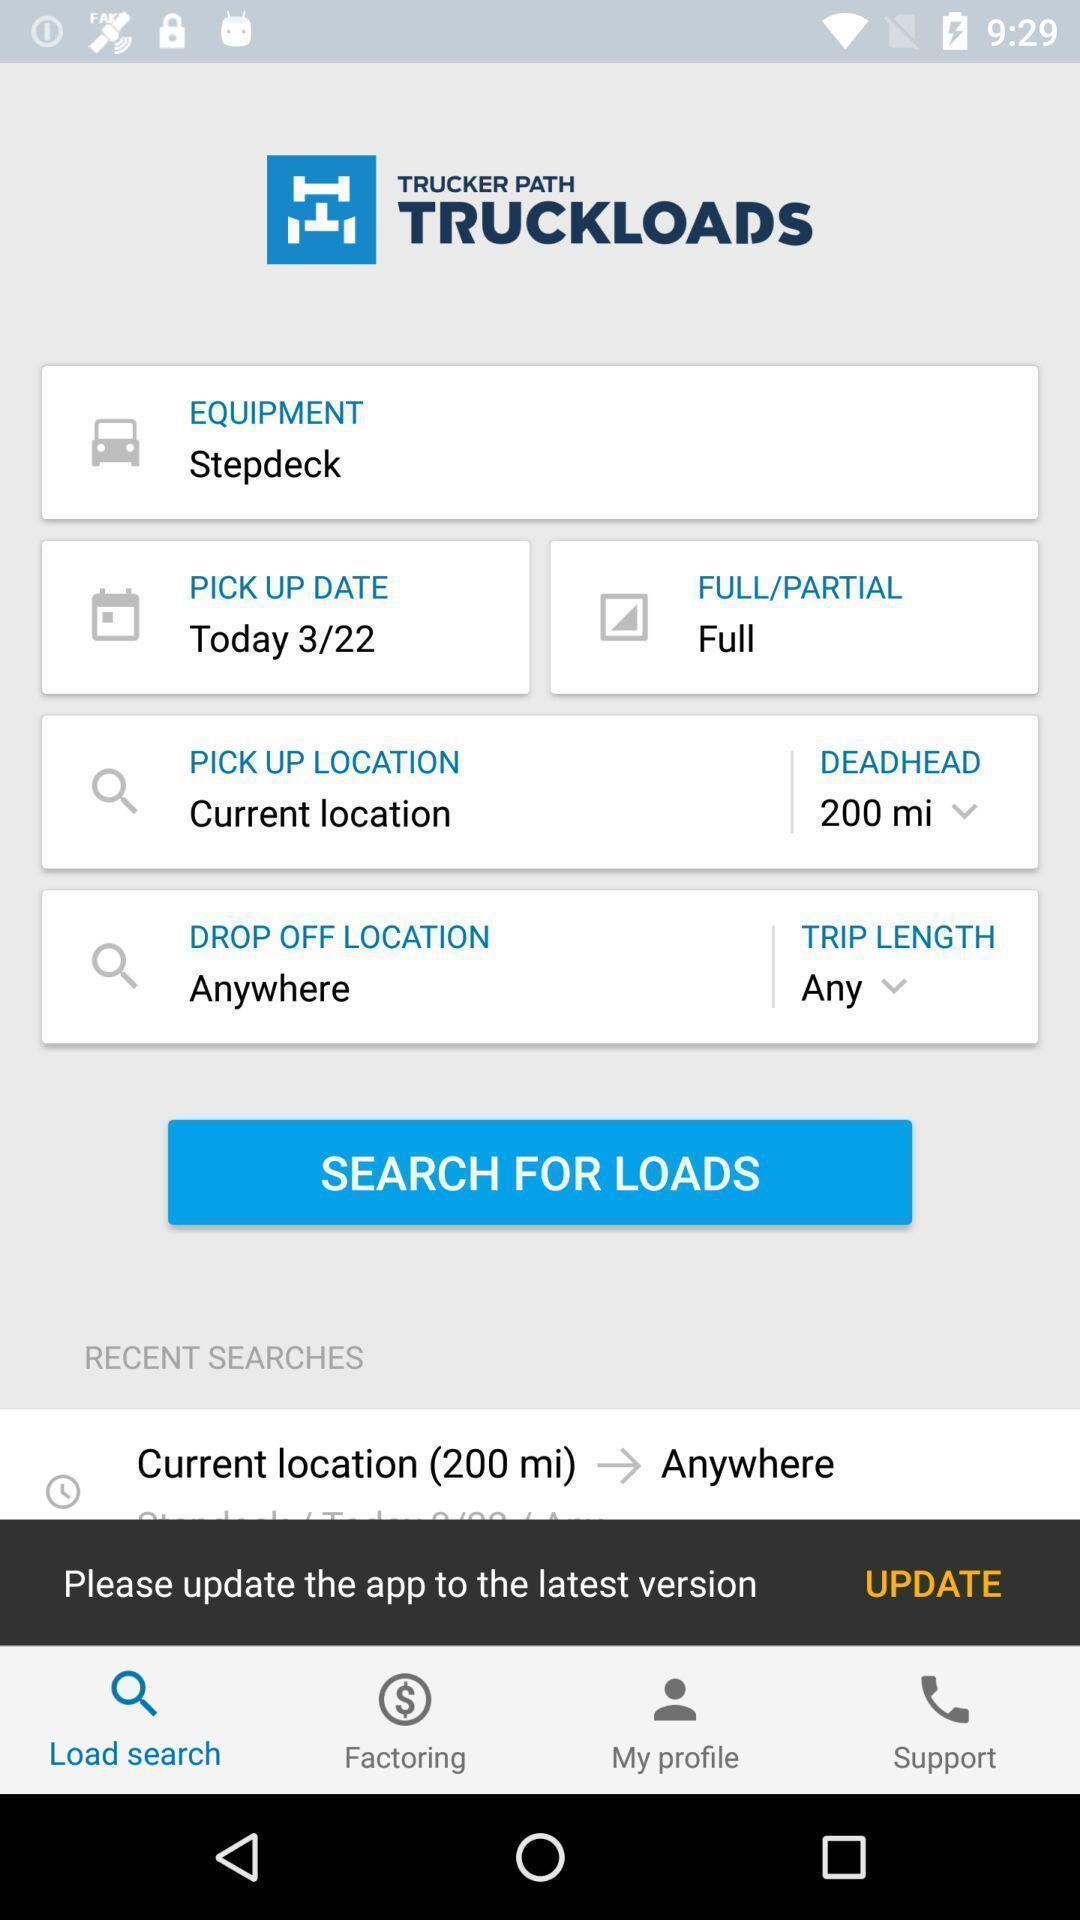Tell me what you see in this picture. Search page showing options. 